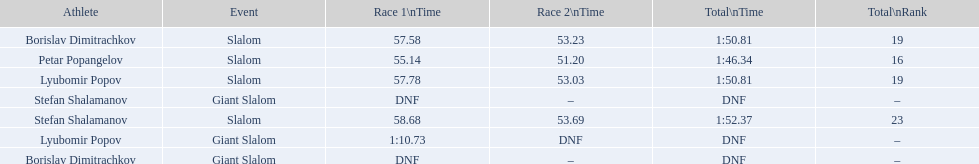What were the event names during bulgaria at the 1988 winter olympics? Stefan Shalamanov, Borislav Dimitrachkov, Lyubomir Popov. And which players participated at giant slalom? Giant Slalom, Giant Slalom, Giant Slalom, Slalom, Slalom, Slalom, Slalom. What were their race 1 times? DNF, DNF, 1:10.73. What was lyubomir popov's personal time? 1:10.73. 